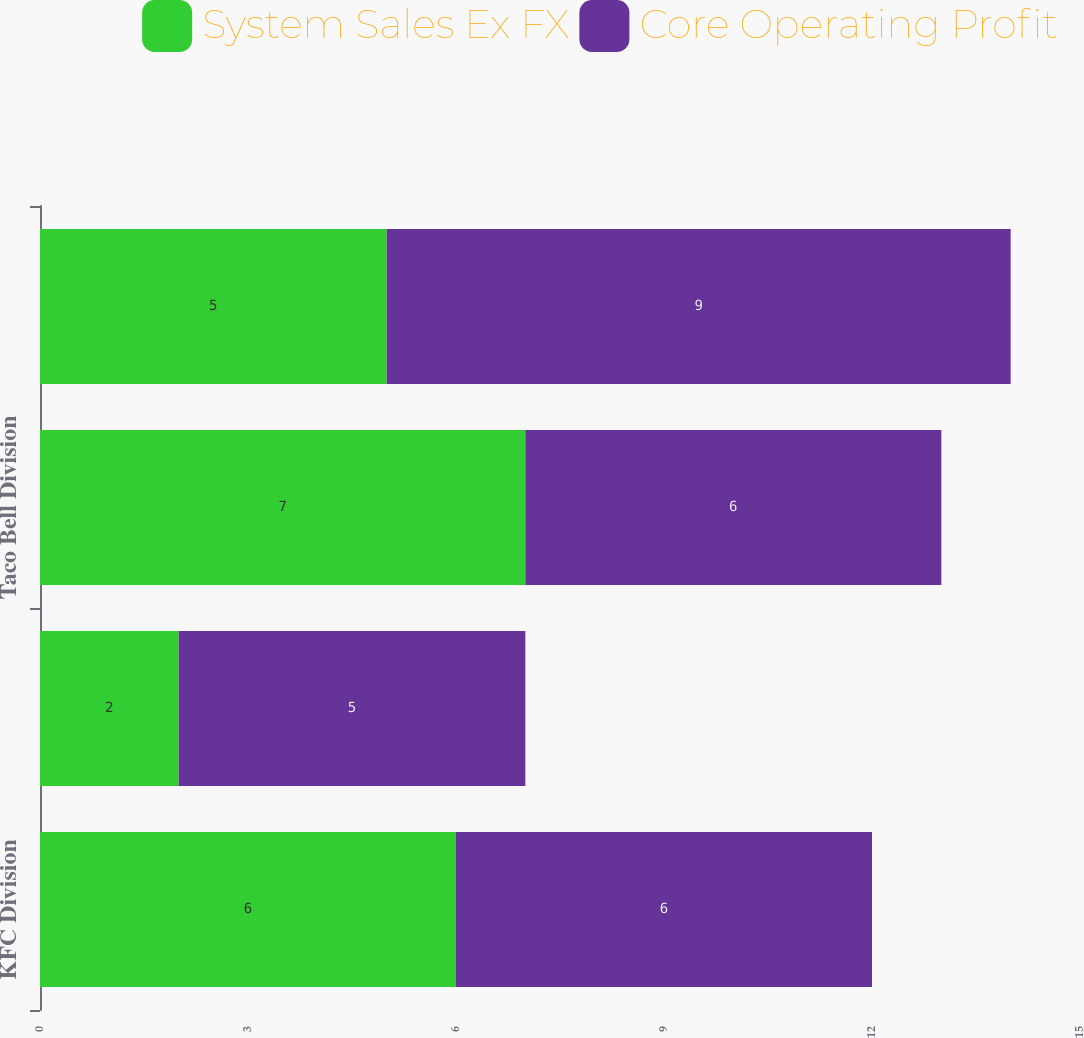<chart> <loc_0><loc_0><loc_500><loc_500><stacked_bar_chart><ecel><fcel>KFC Division<fcel>Pizza Hut Division<fcel>Taco Bell Division<fcel>Worldwide<nl><fcel>System Sales Ex FX<fcel>6<fcel>2<fcel>7<fcel>5<nl><fcel>Core Operating Profit<fcel>6<fcel>5<fcel>6<fcel>9<nl></chart> 